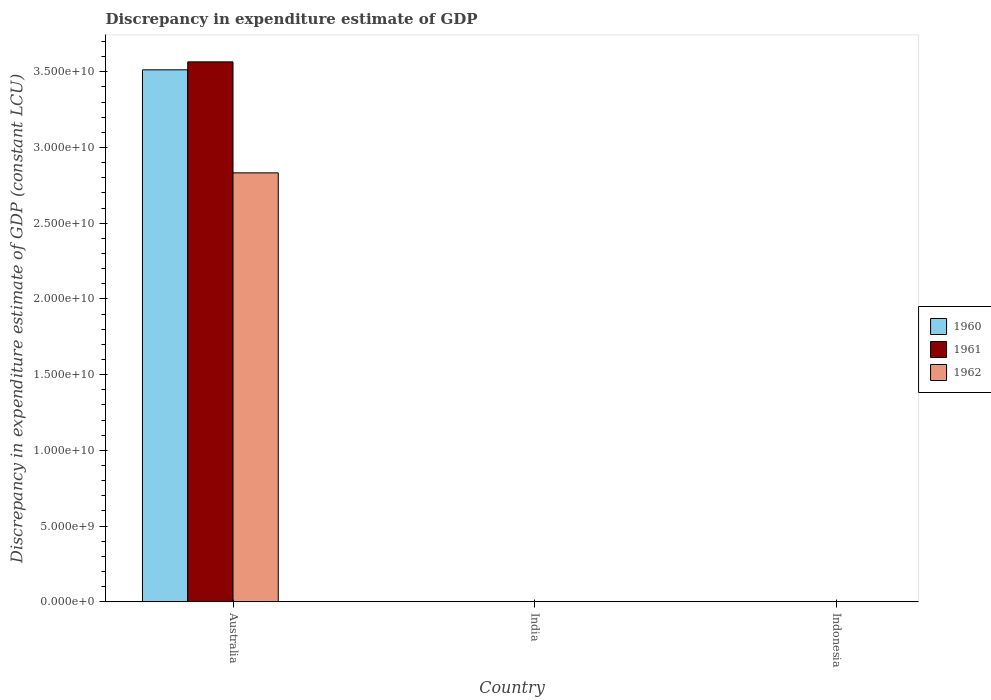How many bars are there on the 1st tick from the left?
Keep it short and to the point. 3. How many bars are there on the 2nd tick from the right?
Provide a succinct answer. 0. What is the label of the 3rd group of bars from the left?
Your response must be concise. Indonesia. In how many cases, is the number of bars for a given country not equal to the number of legend labels?
Keep it short and to the point. 2. Across all countries, what is the maximum discrepancy in expenditure estimate of GDP in 1961?
Your answer should be very brief. 3.56e+1. Across all countries, what is the minimum discrepancy in expenditure estimate of GDP in 1961?
Your answer should be very brief. 0. In which country was the discrepancy in expenditure estimate of GDP in 1960 maximum?
Keep it short and to the point. Australia. What is the total discrepancy in expenditure estimate of GDP in 1960 in the graph?
Make the answer very short. 3.51e+1. What is the difference between the discrepancy in expenditure estimate of GDP in 1962 in Australia and the discrepancy in expenditure estimate of GDP in 1961 in India?
Offer a very short reply. 2.83e+1. What is the average discrepancy in expenditure estimate of GDP in 1961 per country?
Offer a terse response. 1.19e+1. What is the difference between the discrepancy in expenditure estimate of GDP of/in 1962 and discrepancy in expenditure estimate of GDP of/in 1960 in Australia?
Your response must be concise. -6.80e+09. In how many countries, is the discrepancy in expenditure estimate of GDP in 1962 greater than 10000000000 LCU?
Keep it short and to the point. 1. What is the difference between the highest and the lowest discrepancy in expenditure estimate of GDP in 1961?
Your response must be concise. 3.56e+1. Is it the case that in every country, the sum of the discrepancy in expenditure estimate of GDP in 1962 and discrepancy in expenditure estimate of GDP in 1960 is greater than the discrepancy in expenditure estimate of GDP in 1961?
Offer a very short reply. No. Are all the bars in the graph horizontal?
Ensure brevity in your answer.  No. How are the legend labels stacked?
Offer a very short reply. Vertical. What is the title of the graph?
Your response must be concise. Discrepancy in expenditure estimate of GDP. What is the label or title of the Y-axis?
Your answer should be compact. Discrepancy in expenditure estimate of GDP (constant LCU). What is the Discrepancy in expenditure estimate of GDP (constant LCU) in 1960 in Australia?
Offer a very short reply. 3.51e+1. What is the Discrepancy in expenditure estimate of GDP (constant LCU) of 1961 in Australia?
Provide a short and direct response. 3.56e+1. What is the Discrepancy in expenditure estimate of GDP (constant LCU) of 1962 in Australia?
Offer a terse response. 2.83e+1. What is the Discrepancy in expenditure estimate of GDP (constant LCU) of 1962 in India?
Your answer should be very brief. 0. What is the Discrepancy in expenditure estimate of GDP (constant LCU) of 1961 in Indonesia?
Your answer should be compact. 0. What is the Discrepancy in expenditure estimate of GDP (constant LCU) in 1962 in Indonesia?
Provide a succinct answer. 0. Across all countries, what is the maximum Discrepancy in expenditure estimate of GDP (constant LCU) in 1960?
Ensure brevity in your answer.  3.51e+1. Across all countries, what is the maximum Discrepancy in expenditure estimate of GDP (constant LCU) of 1961?
Make the answer very short. 3.56e+1. Across all countries, what is the maximum Discrepancy in expenditure estimate of GDP (constant LCU) in 1962?
Provide a short and direct response. 2.83e+1. What is the total Discrepancy in expenditure estimate of GDP (constant LCU) in 1960 in the graph?
Make the answer very short. 3.51e+1. What is the total Discrepancy in expenditure estimate of GDP (constant LCU) in 1961 in the graph?
Offer a very short reply. 3.56e+1. What is the total Discrepancy in expenditure estimate of GDP (constant LCU) of 1962 in the graph?
Your answer should be very brief. 2.83e+1. What is the average Discrepancy in expenditure estimate of GDP (constant LCU) of 1960 per country?
Keep it short and to the point. 1.17e+1. What is the average Discrepancy in expenditure estimate of GDP (constant LCU) of 1961 per country?
Make the answer very short. 1.19e+1. What is the average Discrepancy in expenditure estimate of GDP (constant LCU) in 1962 per country?
Make the answer very short. 9.44e+09. What is the difference between the Discrepancy in expenditure estimate of GDP (constant LCU) of 1960 and Discrepancy in expenditure estimate of GDP (constant LCU) of 1961 in Australia?
Give a very brief answer. -5.25e+08. What is the difference between the Discrepancy in expenditure estimate of GDP (constant LCU) of 1960 and Discrepancy in expenditure estimate of GDP (constant LCU) of 1962 in Australia?
Your answer should be very brief. 6.80e+09. What is the difference between the Discrepancy in expenditure estimate of GDP (constant LCU) in 1961 and Discrepancy in expenditure estimate of GDP (constant LCU) in 1962 in Australia?
Your response must be concise. 7.33e+09. What is the difference between the highest and the lowest Discrepancy in expenditure estimate of GDP (constant LCU) in 1960?
Make the answer very short. 3.51e+1. What is the difference between the highest and the lowest Discrepancy in expenditure estimate of GDP (constant LCU) in 1961?
Your answer should be very brief. 3.56e+1. What is the difference between the highest and the lowest Discrepancy in expenditure estimate of GDP (constant LCU) in 1962?
Your answer should be very brief. 2.83e+1. 